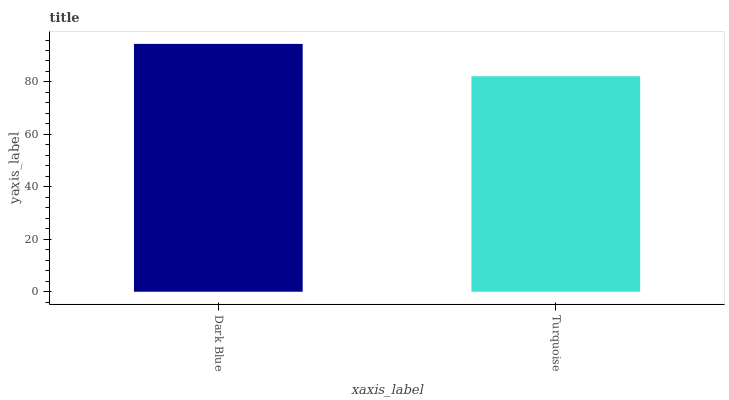Is Turquoise the minimum?
Answer yes or no. Yes. Is Dark Blue the maximum?
Answer yes or no. Yes. Is Turquoise the maximum?
Answer yes or no. No. Is Dark Blue greater than Turquoise?
Answer yes or no. Yes. Is Turquoise less than Dark Blue?
Answer yes or no. Yes. Is Turquoise greater than Dark Blue?
Answer yes or no. No. Is Dark Blue less than Turquoise?
Answer yes or no. No. Is Dark Blue the high median?
Answer yes or no. Yes. Is Turquoise the low median?
Answer yes or no. Yes. Is Turquoise the high median?
Answer yes or no. No. Is Dark Blue the low median?
Answer yes or no. No. 